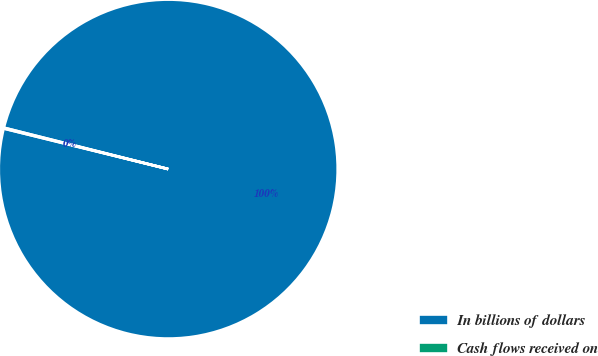<chart> <loc_0><loc_0><loc_500><loc_500><pie_chart><fcel>In billions of dollars<fcel>Cash flows received on<nl><fcel>99.92%<fcel>0.08%<nl></chart> 